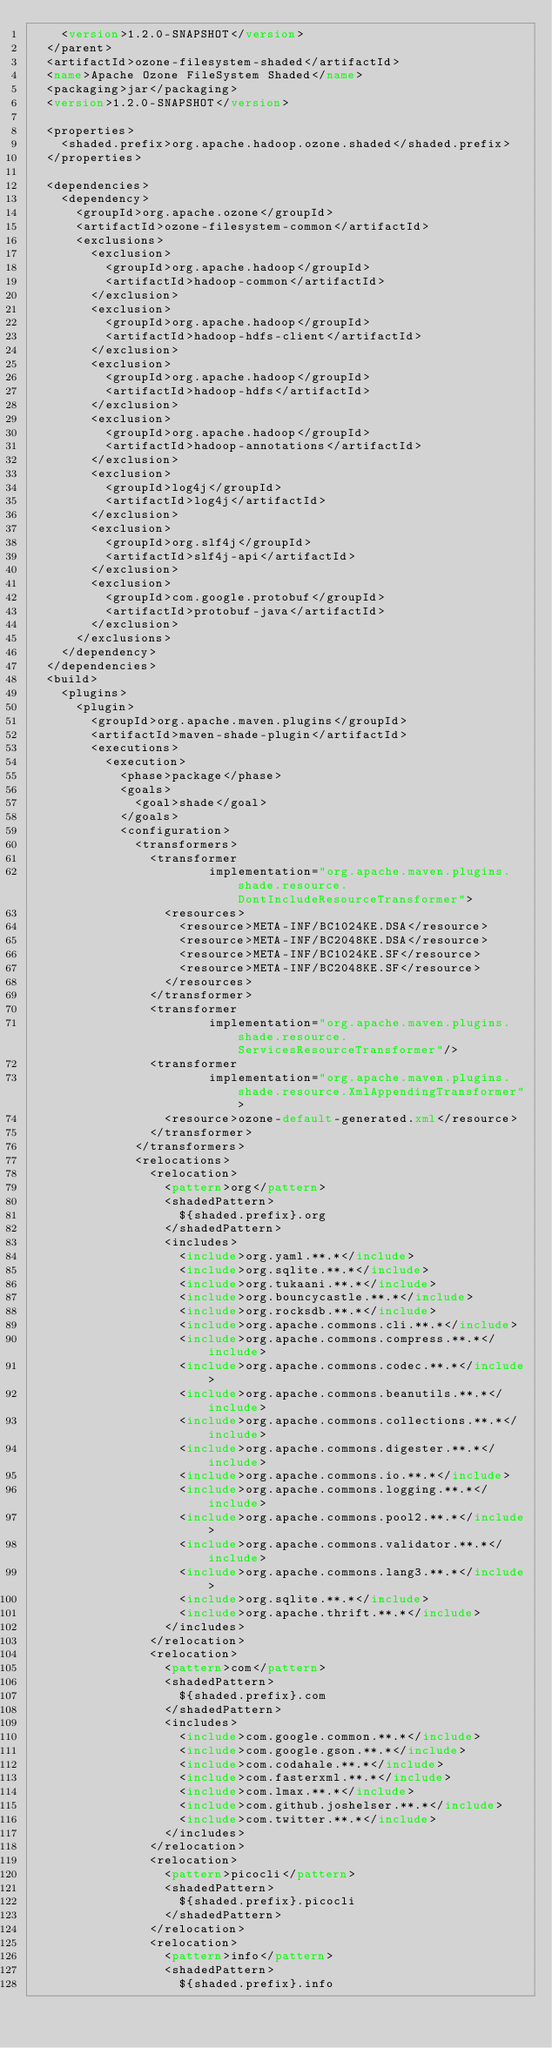<code> <loc_0><loc_0><loc_500><loc_500><_XML_>    <version>1.2.0-SNAPSHOT</version>
  </parent>
  <artifactId>ozone-filesystem-shaded</artifactId>
  <name>Apache Ozone FileSystem Shaded</name>
  <packaging>jar</packaging>
  <version>1.2.0-SNAPSHOT</version>

  <properties>
    <shaded.prefix>org.apache.hadoop.ozone.shaded</shaded.prefix>
  </properties>

  <dependencies>
    <dependency>
      <groupId>org.apache.ozone</groupId>
      <artifactId>ozone-filesystem-common</artifactId>
      <exclusions>
        <exclusion>
          <groupId>org.apache.hadoop</groupId>
          <artifactId>hadoop-common</artifactId>
        </exclusion>
        <exclusion>
          <groupId>org.apache.hadoop</groupId>
          <artifactId>hadoop-hdfs-client</artifactId>
        </exclusion>
        <exclusion>
          <groupId>org.apache.hadoop</groupId>
          <artifactId>hadoop-hdfs</artifactId>
        </exclusion>
        <exclusion>
          <groupId>org.apache.hadoop</groupId>
          <artifactId>hadoop-annotations</artifactId>
        </exclusion>
        <exclusion>
          <groupId>log4j</groupId>
          <artifactId>log4j</artifactId>
        </exclusion>
        <exclusion>
          <groupId>org.slf4j</groupId>
          <artifactId>slf4j-api</artifactId>
        </exclusion>
        <exclusion>
          <groupId>com.google.protobuf</groupId>
          <artifactId>protobuf-java</artifactId>
        </exclusion>
      </exclusions>
    </dependency>
  </dependencies>
  <build>
    <plugins>
      <plugin>
        <groupId>org.apache.maven.plugins</groupId>
        <artifactId>maven-shade-plugin</artifactId>
        <executions>
          <execution>
            <phase>package</phase>
            <goals>
              <goal>shade</goal>
            </goals>
            <configuration>
              <transformers>
                <transformer
                        implementation="org.apache.maven.plugins.shade.resource.DontIncludeResourceTransformer">
                  <resources>
                    <resource>META-INF/BC1024KE.DSA</resource>
                    <resource>META-INF/BC2048KE.DSA</resource>
                    <resource>META-INF/BC1024KE.SF</resource>
                    <resource>META-INF/BC2048KE.SF</resource>
                  </resources>
                </transformer>
                <transformer
                        implementation="org.apache.maven.plugins.shade.resource.ServicesResourceTransformer"/>
                <transformer
                        implementation="org.apache.maven.plugins.shade.resource.XmlAppendingTransformer">
                  <resource>ozone-default-generated.xml</resource>
                </transformer>
              </transformers>
              <relocations>
                <relocation>
                  <pattern>org</pattern>
                  <shadedPattern>
                    ${shaded.prefix}.org
                  </shadedPattern>
                  <includes>
                    <include>org.yaml.**.*</include>
                    <include>org.sqlite.**.*</include>
                    <include>org.tukaani.**.*</include>
                    <include>org.bouncycastle.**.*</include>
                    <include>org.rocksdb.**.*</include>
                    <include>org.apache.commons.cli.**.*</include>
                    <include>org.apache.commons.compress.**.*</include>
                    <include>org.apache.commons.codec.**.*</include>
                    <include>org.apache.commons.beanutils.**.*</include>
                    <include>org.apache.commons.collections.**.*</include>
                    <include>org.apache.commons.digester.**.*</include>
                    <include>org.apache.commons.io.**.*</include>
                    <include>org.apache.commons.logging.**.*</include>
                    <include>org.apache.commons.pool2.**.*</include>
                    <include>org.apache.commons.validator.**.*</include>
                    <include>org.apache.commons.lang3.**.*</include>
                    <include>org.sqlite.**.*</include>
                    <include>org.apache.thrift.**.*</include>
                  </includes>
                </relocation>
                <relocation>
                  <pattern>com</pattern>
                  <shadedPattern>
                    ${shaded.prefix}.com
                  </shadedPattern>
                  <includes>
                    <include>com.google.common.**.*</include>
                    <include>com.google.gson.**.*</include>
                    <include>com.codahale.**.*</include>
                    <include>com.fasterxml.**.*</include>
                    <include>com.lmax.**.*</include>
                    <include>com.github.joshelser.**.*</include>
                    <include>com.twitter.**.*</include>
                  </includes>
                </relocation>
                <relocation>
                  <pattern>picocli</pattern>
                  <shadedPattern>
                    ${shaded.prefix}.picocli
                  </shadedPattern>
                </relocation>
                <relocation>
                  <pattern>info</pattern>
                  <shadedPattern>
                    ${shaded.prefix}.info</code> 